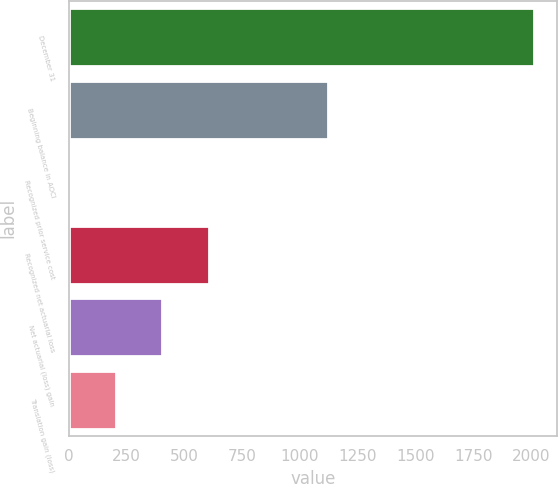Convert chart. <chart><loc_0><loc_0><loc_500><loc_500><bar_chart><fcel>December 31<fcel>Beginning balance in AOCI<fcel>Recognized prior service cost<fcel>Recognized net actuarial loss<fcel>Net actuarial (loss) gain<fcel>Translation gain (loss)<nl><fcel>2010<fcel>1119<fcel>5<fcel>606.5<fcel>406<fcel>205.5<nl></chart> 